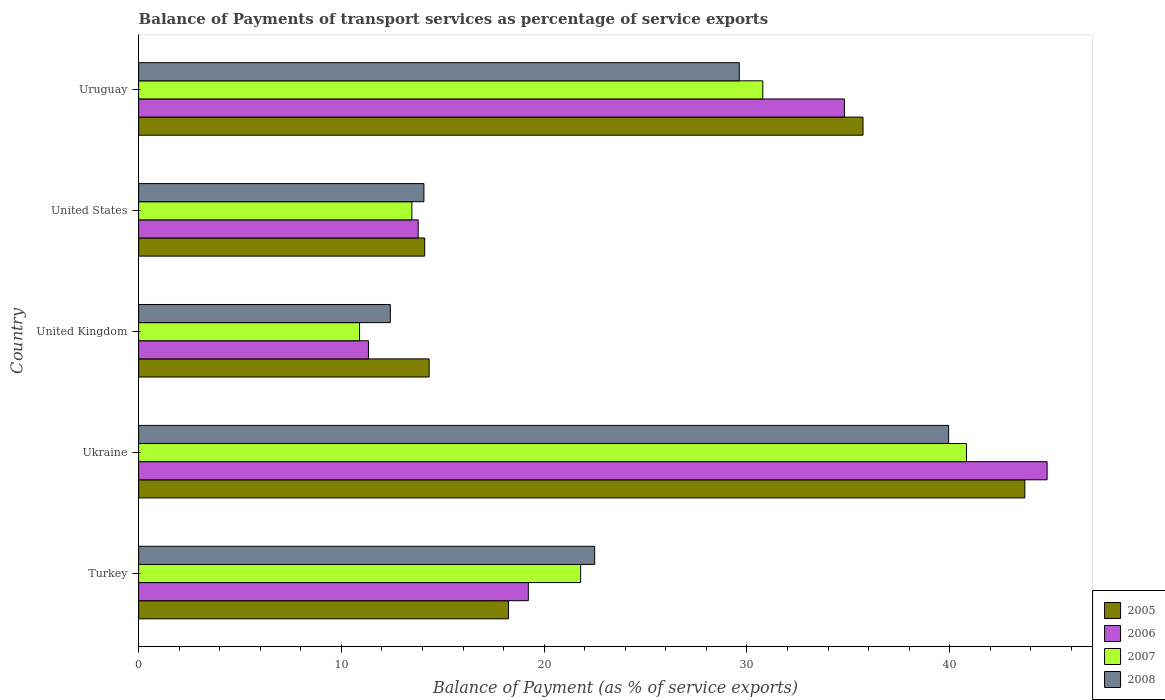How many different coloured bars are there?
Ensure brevity in your answer.  4. Are the number of bars on each tick of the Y-axis equal?
Provide a succinct answer. Yes. How many bars are there on the 1st tick from the top?
Give a very brief answer. 4. What is the label of the 1st group of bars from the top?
Give a very brief answer. Uruguay. What is the balance of payments of transport services in 2007 in United States?
Your answer should be very brief. 13.48. Across all countries, what is the maximum balance of payments of transport services in 2006?
Give a very brief answer. 44.81. Across all countries, what is the minimum balance of payments of transport services in 2006?
Keep it short and to the point. 11.33. In which country was the balance of payments of transport services in 2005 maximum?
Your answer should be compact. Ukraine. In which country was the balance of payments of transport services in 2008 minimum?
Offer a very short reply. United Kingdom. What is the total balance of payments of transport services in 2007 in the graph?
Give a very brief answer. 117.79. What is the difference between the balance of payments of transport services in 2008 in Ukraine and that in United States?
Provide a short and direct response. 25.88. What is the difference between the balance of payments of transport services in 2006 in United States and the balance of payments of transport services in 2008 in United Kingdom?
Your answer should be very brief. 1.37. What is the average balance of payments of transport services in 2006 per country?
Ensure brevity in your answer.  24.79. What is the difference between the balance of payments of transport services in 2005 and balance of payments of transport services in 2006 in United States?
Ensure brevity in your answer.  0.32. What is the ratio of the balance of payments of transport services in 2006 in Ukraine to that in United States?
Give a very brief answer. 3.25. What is the difference between the highest and the second highest balance of payments of transport services in 2007?
Offer a very short reply. 10.05. What is the difference between the highest and the lowest balance of payments of transport services in 2007?
Provide a succinct answer. 29.93. In how many countries, is the balance of payments of transport services in 2007 greater than the average balance of payments of transport services in 2007 taken over all countries?
Offer a very short reply. 2. Is it the case that in every country, the sum of the balance of payments of transport services in 2007 and balance of payments of transport services in 2006 is greater than the sum of balance of payments of transport services in 2005 and balance of payments of transport services in 2008?
Provide a succinct answer. No. What does the 4th bar from the bottom in Ukraine represents?
Ensure brevity in your answer.  2008. Is it the case that in every country, the sum of the balance of payments of transport services in 2008 and balance of payments of transport services in 2005 is greater than the balance of payments of transport services in 2007?
Your response must be concise. Yes. Are all the bars in the graph horizontal?
Provide a short and direct response. Yes. How many countries are there in the graph?
Ensure brevity in your answer.  5. What is the difference between two consecutive major ticks on the X-axis?
Your answer should be compact. 10. Does the graph contain grids?
Give a very brief answer. No. How are the legend labels stacked?
Offer a very short reply. Vertical. What is the title of the graph?
Provide a succinct answer. Balance of Payments of transport services as percentage of service exports. What is the label or title of the X-axis?
Offer a terse response. Balance of Payment (as % of service exports). What is the label or title of the Y-axis?
Your response must be concise. Country. What is the Balance of Payment (as % of service exports) in 2005 in Turkey?
Make the answer very short. 18.24. What is the Balance of Payment (as % of service exports) of 2006 in Turkey?
Provide a succinct answer. 19.22. What is the Balance of Payment (as % of service exports) of 2007 in Turkey?
Offer a terse response. 21.8. What is the Balance of Payment (as % of service exports) of 2008 in Turkey?
Make the answer very short. 22.49. What is the Balance of Payment (as % of service exports) of 2005 in Ukraine?
Provide a succinct answer. 43.71. What is the Balance of Payment (as % of service exports) of 2006 in Ukraine?
Make the answer very short. 44.81. What is the Balance of Payment (as % of service exports) in 2007 in Ukraine?
Ensure brevity in your answer.  40.83. What is the Balance of Payment (as % of service exports) in 2008 in Ukraine?
Keep it short and to the point. 39.95. What is the Balance of Payment (as % of service exports) of 2005 in United Kingdom?
Offer a terse response. 14.33. What is the Balance of Payment (as % of service exports) in 2006 in United Kingdom?
Provide a short and direct response. 11.33. What is the Balance of Payment (as % of service exports) in 2007 in United Kingdom?
Provide a short and direct response. 10.9. What is the Balance of Payment (as % of service exports) in 2008 in United Kingdom?
Your response must be concise. 12.41. What is the Balance of Payment (as % of service exports) in 2005 in United States?
Keep it short and to the point. 14.11. What is the Balance of Payment (as % of service exports) of 2006 in United States?
Keep it short and to the point. 13.79. What is the Balance of Payment (as % of service exports) of 2007 in United States?
Provide a short and direct response. 13.48. What is the Balance of Payment (as % of service exports) of 2008 in United States?
Ensure brevity in your answer.  14.07. What is the Balance of Payment (as % of service exports) in 2005 in Uruguay?
Your answer should be very brief. 35.73. What is the Balance of Payment (as % of service exports) of 2006 in Uruguay?
Make the answer very short. 34.81. What is the Balance of Payment (as % of service exports) of 2007 in Uruguay?
Provide a succinct answer. 30.78. What is the Balance of Payment (as % of service exports) of 2008 in Uruguay?
Offer a terse response. 29.62. Across all countries, what is the maximum Balance of Payment (as % of service exports) of 2005?
Give a very brief answer. 43.71. Across all countries, what is the maximum Balance of Payment (as % of service exports) in 2006?
Offer a terse response. 44.81. Across all countries, what is the maximum Balance of Payment (as % of service exports) in 2007?
Provide a succinct answer. 40.83. Across all countries, what is the maximum Balance of Payment (as % of service exports) of 2008?
Make the answer very short. 39.95. Across all countries, what is the minimum Balance of Payment (as % of service exports) in 2005?
Provide a short and direct response. 14.11. Across all countries, what is the minimum Balance of Payment (as % of service exports) in 2006?
Provide a short and direct response. 11.33. Across all countries, what is the minimum Balance of Payment (as % of service exports) in 2007?
Give a very brief answer. 10.9. Across all countries, what is the minimum Balance of Payment (as % of service exports) in 2008?
Provide a succinct answer. 12.41. What is the total Balance of Payment (as % of service exports) in 2005 in the graph?
Keep it short and to the point. 126.12. What is the total Balance of Payment (as % of service exports) of 2006 in the graph?
Offer a very short reply. 123.96. What is the total Balance of Payment (as % of service exports) of 2007 in the graph?
Provide a succinct answer. 117.79. What is the total Balance of Payment (as % of service exports) in 2008 in the graph?
Your answer should be compact. 118.55. What is the difference between the Balance of Payment (as % of service exports) in 2005 in Turkey and that in Ukraine?
Make the answer very short. -25.46. What is the difference between the Balance of Payment (as % of service exports) of 2006 in Turkey and that in Ukraine?
Give a very brief answer. -25.59. What is the difference between the Balance of Payment (as % of service exports) of 2007 in Turkey and that in Ukraine?
Keep it short and to the point. -19.03. What is the difference between the Balance of Payment (as % of service exports) of 2008 in Turkey and that in Ukraine?
Make the answer very short. -17.46. What is the difference between the Balance of Payment (as % of service exports) of 2005 in Turkey and that in United Kingdom?
Keep it short and to the point. 3.92. What is the difference between the Balance of Payment (as % of service exports) of 2006 in Turkey and that in United Kingdom?
Your answer should be compact. 7.89. What is the difference between the Balance of Payment (as % of service exports) of 2007 in Turkey and that in United Kingdom?
Your answer should be compact. 10.9. What is the difference between the Balance of Payment (as % of service exports) of 2008 in Turkey and that in United Kingdom?
Offer a very short reply. 10.08. What is the difference between the Balance of Payment (as % of service exports) of 2005 in Turkey and that in United States?
Make the answer very short. 4.14. What is the difference between the Balance of Payment (as % of service exports) of 2006 in Turkey and that in United States?
Your response must be concise. 5.43. What is the difference between the Balance of Payment (as % of service exports) in 2007 in Turkey and that in United States?
Give a very brief answer. 8.32. What is the difference between the Balance of Payment (as % of service exports) in 2008 in Turkey and that in United States?
Your answer should be compact. 8.42. What is the difference between the Balance of Payment (as % of service exports) in 2005 in Turkey and that in Uruguay?
Your response must be concise. -17.48. What is the difference between the Balance of Payment (as % of service exports) in 2006 in Turkey and that in Uruguay?
Your answer should be compact. -15.59. What is the difference between the Balance of Payment (as % of service exports) in 2007 in Turkey and that in Uruguay?
Your response must be concise. -8.98. What is the difference between the Balance of Payment (as % of service exports) of 2008 in Turkey and that in Uruguay?
Keep it short and to the point. -7.13. What is the difference between the Balance of Payment (as % of service exports) of 2005 in Ukraine and that in United Kingdom?
Keep it short and to the point. 29.38. What is the difference between the Balance of Payment (as % of service exports) of 2006 in Ukraine and that in United Kingdom?
Offer a terse response. 33.47. What is the difference between the Balance of Payment (as % of service exports) in 2007 in Ukraine and that in United Kingdom?
Provide a succinct answer. 29.93. What is the difference between the Balance of Payment (as % of service exports) of 2008 in Ukraine and that in United Kingdom?
Keep it short and to the point. 27.54. What is the difference between the Balance of Payment (as % of service exports) in 2005 in Ukraine and that in United States?
Your answer should be very brief. 29.6. What is the difference between the Balance of Payment (as % of service exports) in 2006 in Ukraine and that in United States?
Provide a short and direct response. 31.02. What is the difference between the Balance of Payment (as % of service exports) of 2007 in Ukraine and that in United States?
Your answer should be very brief. 27.35. What is the difference between the Balance of Payment (as % of service exports) in 2008 in Ukraine and that in United States?
Provide a short and direct response. 25.88. What is the difference between the Balance of Payment (as % of service exports) of 2005 in Ukraine and that in Uruguay?
Offer a terse response. 7.98. What is the difference between the Balance of Payment (as % of service exports) of 2006 in Ukraine and that in Uruguay?
Your answer should be compact. 10. What is the difference between the Balance of Payment (as % of service exports) in 2007 in Ukraine and that in Uruguay?
Offer a terse response. 10.05. What is the difference between the Balance of Payment (as % of service exports) of 2008 in Ukraine and that in Uruguay?
Offer a terse response. 10.32. What is the difference between the Balance of Payment (as % of service exports) of 2005 in United Kingdom and that in United States?
Your response must be concise. 0.22. What is the difference between the Balance of Payment (as % of service exports) in 2006 in United Kingdom and that in United States?
Offer a terse response. -2.45. What is the difference between the Balance of Payment (as % of service exports) in 2007 in United Kingdom and that in United States?
Provide a succinct answer. -2.58. What is the difference between the Balance of Payment (as % of service exports) in 2008 in United Kingdom and that in United States?
Your answer should be very brief. -1.66. What is the difference between the Balance of Payment (as % of service exports) in 2005 in United Kingdom and that in Uruguay?
Offer a very short reply. -21.4. What is the difference between the Balance of Payment (as % of service exports) of 2006 in United Kingdom and that in Uruguay?
Offer a terse response. -23.47. What is the difference between the Balance of Payment (as % of service exports) in 2007 in United Kingdom and that in Uruguay?
Your answer should be very brief. -19.89. What is the difference between the Balance of Payment (as % of service exports) of 2008 in United Kingdom and that in Uruguay?
Make the answer very short. -17.21. What is the difference between the Balance of Payment (as % of service exports) in 2005 in United States and that in Uruguay?
Ensure brevity in your answer.  -21.62. What is the difference between the Balance of Payment (as % of service exports) in 2006 in United States and that in Uruguay?
Offer a terse response. -21.02. What is the difference between the Balance of Payment (as % of service exports) in 2007 in United States and that in Uruguay?
Offer a terse response. -17.31. What is the difference between the Balance of Payment (as % of service exports) of 2008 in United States and that in Uruguay?
Your answer should be compact. -15.55. What is the difference between the Balance of Payment (as % of service exports) in 2005 in Turkey and the Balance of Payment (as % of service exports) in 2006 in Ukraine?
Your answer should be very brief. -26.56. What is the difference between the Balance of Payment (as % of service exports) of 2005 in Turkey and the Balance of Payment (as % of service exports) of 2007 in Ukraine?
Ensure brevity in your answer.  -22.58. What is the difference between the Balance of Payment (as % of service exports) in 2005 in Turkey and the Balance of Payment (as % of service exports) in 2008 in Ukraine?
Ensure brevity in your answer.  -21.7. What is the difference between the Balance of Payment (as % of service exports) of 2006 in Turkey and the Balance of Payment (as % of service exports) of 2007 in Ukraine?
Give a very brief answer. -21.61. What is the difference between the Balance of Payment (as % of service exports) of 2006 in Turkey and the Balance of Payment (as % of service exports) of 2008 in Ukraine?
Provide a short and direct response. -20.73. What is the difference between the Balance of Payment (as % of service exports) in 2007 in Turkey and the Balance of Payment (as % of service exports) in 2008 in Ukraine?
Your response must be concise. -18.15. What is the difference between the Balance of Payment (as % of service exports) in 2005 in Turkey and the Balance of Payment (as % of service exports) in 2006 in United Kingdom?
Make the answer very short. 6.91. What is the difference between the Balance of Payment (as % of service exports) of 2005 in Turkey and the Balance of Payment (as % of service exports) of 2007 in United Kingdom?
Your answer should be compact. 7.35. What is the difference between the Balance of Payment (as % of service exports) of 2005 in Turkey and the Balance of Payment (as % of service exports) of 2008 in United Kingdom?
Offer a terse response. 5.83. What is the difference between the Balance of Payment (as % of service exports) of 2006 in Turkey and the Balance of Payment (as % of service exports) of 2007 in United Kingdom?
Your answer should be very brief. 8.32. What is the difference between the Balance of Payment (as % of service exports) in 2006 in Turkey and the Balance of Payment (as % of service exports) in 2008 in United Kingdom?
Offer a terse response. 6.81. What is the difference between the Balance of Payment (as % of service exports) of 2007 in Turkey and the Balance of Payment (as % of service exports) of 2008 in United Kingdom?
Give a very brief answer. 9.39. What is the difference between the Balance of Payment (as % of service exports) of 2005 in Turkey and the Balance of Payment (as % of service exports) of 2006 in United States?
Offer a very short reply. 4.46. What is the difference between the Balance of Payment (as % of service exports) in 2005 in Turkey and the Balance of Payment (as % of service exports) in 2007 in United States?
Your response must be concise. 4.77. What is the difference between the Balance of Payment (as % of service exports) in 2005 in Turkey and the Balance of Payment (as % of service exports) in 2008 in United States?
Your answer should be compact. 4.17. What is the difference between the Balance of Payment (as % of service exports) in 2006 in Turkey and the Balance of Payment (as % of service exports) in 2007 in United States?
Ensure brevity in your answer.  5.74. What is the difference between the Balance of Payment (as % of service exports) of 2006 in Turkey and the Balance of Payment (as % of service exports) of 2008 in United States?
Your answer should be compact. 5.15. What is the difference between the Balance of Payment (as % of service exports) in 2007 in Turkey and the Balance of Payment (as % of service exports) in 2008 in United States?
Provide a short and direct response. 7.73. What is the difference between the Balance of Payment (as % of service exports) of 2005 in Turkey and the Balance of Payment (as % of service exports) of 2006 in Uruguay?
Your answer should be compact. -16.56. What is the difference between the Balance of Payment (as % of service exports) of 2005 in Turkey and the Balance of Payment (as % of service exports) of 2007 in Uruguay?
Provide a succinct answer. -12.54. What is the difference between the Balance of Payment (as % of service exports) of 2005 in Turkey and the Balance of Payment (as % of service exports) of 2008 in Uruguay?
Your response must be concise. -11.38. What is the difference between the Balance of Payment (as % of service exports) in 2006 in Turkey and the Balance of Payment (as % of service exports) in 2007 in Uruguay?
Provide a succinct answer. -11.56. What is the difference between the Balance of Payment (as % of service exports) of 2006 in Turkey and the Balance of Payment (as % of service exports) of 2008 in Uruguay?
Make the answer very short. -10.4. What is the difference between the Balance of Payment (as % of service exports) in 2007 in Turkey and the Balance of Payment (as % of service exports) in 2008 in Uruguay?
Your answer should be very brief. -7.82. What is the difference between the Balance of Payment (as % of service exports) of 2005 in Ukraine and the Balance of Payment (as % of service exports) of 2006 in United Kingdom?
Keep it short and to the point. 32.37. What is the difference between the Balance of Payment (as % of service exports) in 2005 in Ukraine and the Balance of Payment (as % of service exports) in 2007 in United Kingdom?
Provide a succinct answer. 32.81. What is the difference between the Balance of Payment (as % of service exports) of 2005 in Ukraine and the Balance of Payment (as % of service exports) of 2008 in United Kingdom?
Make the answer very short. 31.29. What is the difference between the Balance of Payment (as % of service exports) in 2006 in Ukraine and the Balance of Payment (as % of service exports) in 2007 in United Kingdom?
Provide a short and direct response. 33.91. What is the difference between the Balance of Payment (as % of service exports) of 2006 in Ukraine and the Balance of Payment (as % of service exports) of 2008 in United Kingdom?
Ensure brevity in your answer.  32.39. What is the difference between the Balance of Payment (as % of service exports) in 2007 in Ukraine and the Balance of Payment (as % of service exports) in 2008 in United Kingdom?
Provide a succinct answer. 28.41. What is the difference between the Balance of Payment (as % of service exports) of 2005 in Ukraine and the Balance of Payment (as % of service exports) of 2006 in United States?
Provide a short and direct response. 29.92. What is the difference between the Balance of Payment (as % of service exports) of 2005 in Ukraine and the Balance of Payment (as % of service exports) of 2007 in United States?
Make the answer very short. 30.23. What is the difference between the Balance of Payment (as % of service exports) of 2005 in Ukraine and the Balance of Payment (as % of service exports) of 2008 in United States?
Offer a terse response. 29.64. What is the difference between the Balance of Payment (as % of service exports) in 2006 in Ukraine and the Balance of Payment (as % of service exports) in 2007 in United States?
Keep it short and to the point. 31.33. What is the difference between the Balance of Payment (as % of service exports) of 2006 in Ukraine and the Balance of Payment (as % of service exports) of 2008 in United States?
Offer a very short reply. 30.74. What is the difference between the Balance of Payment (as % of service exports) of 2007 in Ukraine and the Balance of Payment (as % of service exports) of 2008 in United States?
Ensure brevity in your answer.  26.76. What is the difference between the Balance of Payment (as % of service exports) of 2005 in Ukraine and the Balance of Payment (as % of service exports) of 2006 in Uruguay?
Provide a short and direct response. 8.9. What is the difference between the Balance of Payment (as % of service exports) in 2005 in Ukraine and the Balance of Payment (as % of service exports) in 2007 in Uruguay?
Ensure brevity in your answer.  12.93. What is the difference between the Balance of Payment (as % of service exports) in 2005 in Ukraine and the Balance of Payment (as % of service exports) in 2008 in Uruguay?
Your answer should be very brief. 14.08. What is the difference between the Balance of Payment (as % of service exports) in 2006 in Ukraine and the Balance of Payment (as % of service exports) in 2007 in Uruguay?
Provide a succinct answer. 14.02. What is the difference between the Balance of Payment (as % of service exports) of 2006 in Ukraine and the Balance of Payment (as % of service exports) of 2008 in Uruguay?
Provide a short and direct response. 15.18. What is the difference between the Balance of Payment (as % of service exports) in 2007 in Ukraine and the Balance of Payment (as % of service exports) in 2008 in Uruguay?
Offer a very short reply. 11.21. What is the difference between the Balance of Payment (as % of service exports) of 2005 in United Kingdom and the Balance of Payment (as % of service exports) of 2006 in United States?
Provide a succinct answer. 0.54. What is the difference between the Balance of Payment (as % of service exports) in 2005 in United Kingdom and the Balance of Payment (as % of service exports) in 2007 in United States?
Offer a terse response. 0.85. What is the difference between the Balance of Payment (as % of service exports) in 2005 in United Kingdom and the Balance of Payment (as % of service exports) in 2008 in United States?
Provide a short and direct response. 0.26. What is the difference between the Balance of Payment (as % of service exports) in 2006 in United Kingdom and the Balance of Payment (as % of service exports) in 2007 in United States?
Give a very brief answer. -2.14. What is the difference between the Balance of Payment (as % of service exports) in 2006 in United Kingdom and the Balance of Payment (as % of service exports) in 2008 in United States?
Provide a short and direct response. -2.74. What is the difference between the Balance of Payment (as % of service exports) in 2007 in United Kingdom and the Balance of Payment (as % of service exports) in 2008 in United States?
Provide a short and direct response. -3.17. What is the difference between the Balance of Payment (as % of service exports) in 2005 in United Kingdom and the Balance of Payment (as % of service exports) in 2006 in Uruguay?
Provide a short and direct response. -20.48. What is the difference between the Balance of Payment (as % of service exports) in 2005 in United Kingdom and the Balance of Payment (as % of service exports) in 2007 in Uruguay?
Make the answer very short. -16.45. What is the difference between the Balance of Payment (as % of service exports) of 2005 in United Kingdom and the Balance of Payment (as % of service exports) of 2008 in Uruguay?
Offer a very short reply. -15.3. What is the difference between the Balance of Payment (as % of service exports) in 2006 in United Kingdom and the Balance of Payment (as % of service exports) in 2007 in Uruguay?
Make the answer very short. -19.45. What is the difference between the Balance of Payment (as % of service exports) in 2006 in United Kingdom and the Balance of Payment (as % of service exports) in 2008 in Uruguay?
Offer a terse response. -18.29. What is the difference between the Balance of Payment (as % of service exports) of 2007 in United Kingdom and the Balance of Payment (as % of service exports) of 2008 in Uruguay?
Give a very brief answer. -18.73. What is the difference between the Balance of Payment (as % of service exports) in 2005 in United States and the Balance of Payment (as % of service exports) in 2006 in Uruguay?
Provide a short and direct response. -20.7. What is the difference between the Balance of Payment (as % of service exports) in 2005 in United States and the Balance of Payment (as % of service exports) in 2007 in Uruguay?
Your response must be concise. -16.68. What is the difference between the Balance of Payment (as % of service exports) in 2005 in United States and the Balance of Payment (as % of service exports) in 2008 in Uruguay?
Give a very brief answer. -15.52. What is the difference between the Balance of Payment (as % of service exports) of 2006 in United States and the Balance of Payment (as % of service exports) of 2007 in Uruguay?
Your answer should be very brief. -16.99. What is the difference between the Balance of Payment (as % of service exports) of 2006 in United States and the Balance of Payment (as % of service exports) of 2008 in Uruguay?
Your answer should be compact. -15.84. What is the difference between the Balance of Payment (as % of service exports) of 2007 in United States and the Balance of Payment (as % of service exports) of 2008 in Uruguay?
Provide a short and direct response. -16.15. What is the average Balance of Payment (as % of service exports) of 2005 per country?
Make the answer very short. 25.22. What is the average Balance of Payment (as % of service exports) in 2006 per country?
Offer a very short reply. 24.79. What is the average Balance of Payment (as % of service exports) in 2007 per country?
Make the answer very short. 23.56. What is the average Balance of Payment (as % of service exports) in 2008 per country?
Give a very brief answer. 23.71. What is the difference between the Balance of Payment (as % of service exports) in 2005 and Balance of Payment (as % of service exports) in 2006 in Turkey?
Ensure brevity in your answer.  -0.98. What is the difference between the Balance of Payment (as % of service exports) in 2005 and Balance of Payment (as % of service exports) in 2007 in Turkey?
Offer a terse response. -3.56. What is the difference between the Balance of Payment (as % of service exports) of 2005 and Balance of Payment (as % of service exports) of 2008 in Turkey?
Keep it short and to the point. -4.25. What is the difference between the Balance of Payment (as % of service exports) of 2006 and Balance of Payment (as % of service exports) of 2007 in Turkey?
Keep it short and to the point. -2.58. What is the difference between the Balance of Payment (as % of service exports) in 2006 and Balance of Payment (as % of service exports) in 2008 in Turkey?
Give a very brief answer. -3.27. What is the difference between the Balance of Payment (as % of service exports) of 2007 and Balance of Payment (as % of service exports) of 2008 in Turkey?
Keep it short and to the point. -0.69. What is the difference between the Balance of Payment (as % of service exports) in 2005 and Balance of Payment (as % of service exports) in 2006 in Ukraine?
Make the answer very short. -1.1. What is the difference between the Balance of Payment (as % of service exports) of 2005 and Balance of Payment (as % of service exports) of 2007 in Ukraine?
Your answer should be very brief. 2.88. What is the difference between the Balance of Payment (as % of service exports) in 2005 and Balance of Payment (as % of service exports) in 2008 in Ukraine?
Your answer should be compact. 3.76. What is the difference between the Balance of Payment (as % of service exports) of 2006 and Balance of Payment (as % of service exports) of 2007 in Ukraine?
Offer a terse response. 3.98. What is the difference between the Balance of Payment (as % of service exports) of 2006 and Balance of Payment (as % of service exports) of 2008 in Ukraine?
Your response must be concise. 4.86. What is the difference between the Balance of Payment (as % of service exports) of 2007 and Balance of Payment (as % of service exports) of 2008 in Ukraine?
Offer a very short reply. 0.88. What is the difference between the Balance of Payment (as % of service exports) in 2005 and Balance of Payment (as % of service exports) in 2006 in United Kingdom?
Offer a terse response. 2.99. What is the difference between the Balance of Payment (as % of service exports) of 2005 and Balance of Payment (as % of service exports) of 2007 in United Kingdom?
Make the answer very short. 3.43. What is the difference between the Balance of Payment (as % of service exports) of 2005 and Balance of Payment (as % of service exports) of 2008 in United Kingdom?
Provide a succinct answer. 1.91. What is the difference between the Balance of Payment (as % of service exports) in 2006 and Balance of Payment (as % of service exports) in 2007 in United Kingdom?
Offer a terse response. 0.44. What is the difference between the Balance of Payment (as % of service exports) in 2006 and Balance of Payment (as % of service exports) in 2008 in United Kingdom?
Keep it short and to the point. -1.08. What is the difference between the Balance of Payment (as % of service exports) in 2007 and Balance of Payment (as % of service exports) in 2008 in United Kingdom?
Provide a short and direct response. -1.52. What is the difference between the Balance of Payment (as % of service exports) of 2005 and Balance of Payment (as % of service exports) of 2006 in United States?
Ensure brevity in your answer.  0.32. What is the difference between the Balance of Payment (as % of service exports) of 2005 and Balance of Payment (as % of service exports) of 2007 in United States?
Your answer should be compact. 0.63. What is the difference between the Balance of Payment (as % of service exports) in 2005 and Balance of Payment (as % of service exports) in 2008 in United States?
Your answer should be very brief. 0.04. What is the difference between the Balance of Payment (as % of service exports) in 2006 and Balance of Payment (as % of service exports) in 2007 in United States?
Offer a terse response. 0.31. What is the difference between the Balance of Payment (as % of service exports) in 2006 and Balance of Payment (as % of service exports) in 2008 in United States?
Offer a terse response. -0.28. What is the difference between the Balance of Payment (as % of service exports) of 2007 and Balance of Payment (as % of service exports) of 2008 in United States?
Your answer should be compact. -0.59. What is the difference between the Balance of Payment (as % of service exports) in 2005 and Balance of Payment (as % of service exports) in 2006 in Uruguay?
Make the answer very short. 0.92. What is the difference between the Balance of Payment (as % of service exports) in 2005 and Balance of Payment (as % of service exports) in 2007 in Uruguay?
Provide a short and direct response. 4.94. What is the difference between the Balance of Payment (as % of service exports) of 2005 and Balance of Payment (as % of service exports) of 2008 in Uruguay?
Your answer should be compact. 6.1. What is the difference between the Balance of Payment (as % of service exports) of 2006 and Balance of Payment (as % of service exports) of 2007 in Uruguay?
Ensure brevity in your answer.  4.03. What is the difference between the Balance of Payment (as % of service exports) of 2006 and Balance of Payment (as % of service exports) of 2008 in Uruguay?
Provide a succinct answer. 5.18. What is the difference between the Balance of Payment (as % of service exports) in 2007 and Balance of Payment (as % of service exports) in 2008 in Uruguay?
Offer a terse response. 1.16. What is the ratio of the Balance of Payment (as % of service exports) of 2005 in Turkey to that in Ukraine?
Provide a succinct answer. 0.42. What is the ratio of the Balance of Payment (as % of service exports) in 2006 in Turkey to that in Ukraine?
Keep it short and to the point. 0.43. What is the ratio of the Balance of Payment (as % of service exports) in 2007 in Turkey to that in Ukraine?
Keep it short and to the point. 0.53. What is the ratio of the Balance of Payment (as % of service exports) of 2008 in Turkey to that in Ukraine?
Provide a short and direct response. 0.56. What is the ratio of the Balance of Payment (as % of service exports) of 2005 in Turkey to that in United Kingdom?
Offer a terse response. 1.27. What is the ratio of the Balance of Payment (as % of service exports) in 2006 in Turkey to that in United Kingdom?
Keep it short and to the point. 1.7. What is the ratio of the Balance of Payment (as % of service exports) of 2007 in Turkey to that in United Kingdom?
Offer a very short reply. 2. What is the ratio of the Balance of Payment (as % of service exports) in 2008 in Turkey to that in United Kingdom?
Provide a short and direct response. 1.81. What is the ratio of the Balance of Payment (as % of service exports) of 2005 in Turkey to that in United States?
Make the answer very short. 1.29. What is the ratio of the Balance of Payment (as % of service exports) of 2006 in Turkey to that in United States?
Give a very brief answer. 1.39. What is the ratio of the Balance of Payment (as % of service exports) in 2007 in Turkey to that in United States?
Provide a short and direct response. 1.62. What is the ratio of the Balance of Payment (as % of service exports) of 2008 in Turkey to that in United States?
Your response must be concise. 1.6. What is the ratio of the Balance of Payment (as % of service exports) of 2005 in Turkey to that in Uruguay?
Make the answer very short. 0.51. What is the ratio of the Balance of Payment (as % of service exports) of 2006 in Turkey to that in Uruguay?
Provide a succinct answer. 0.55. What is the ratio of the Balance of Payment (as % of service exports) in 2007 in Turkey to that in Uruguay?
Your answer should be compact. 0.71. What is the ratio of the Balance of Payment (as % of service exports) of 2008 in Turkey to that in Uruguay?
Provide a succinct answer. 0.76. What is the ratio of the Balance of Payment (as % of service exports) in 2005 in Ukraine to that in United Kingdom?
Your answer should be compact. 3.05. What is the ratio of the Balance of Payment (as % of service exports) of 2006 in Ukraine to that in United Kingdom?
Provide a short and direct response. 3.95. What is the ratio of the Balance of Payment (as % of service exports) in 2007 in Ukraine to that in United Kingdom?
Ensure brevity in your answer.  3.75. What is the ratio of the Balance of Payment (as % of service exports) in 2008 in Ukraine to that in United Kingdom?
Provide a short and direct response. 3.22. What is the ratio of the Balance of Payment (as % of service exports) in 2005 in Ukraine to that in United States?
Your response must be concise. 3.1. What is the ratio of the Balance of Payment (as % of service exports) of 2006 in Ukraine to that in United States?
Ensure brevity in your answer.  3.25. What is the ratio of the Balance of Payment (as % of service exports) of 2007 in Ukraine to that in United States?
Your answer should be compact. 3.03. What is the ratio of the Balance of Payment (as % of service exports) of 2008 in Ukraine to that in United States?
Provide a short and direct response. 2.84. What is the ratio of the Balance of Payment (as % of service exports) of 2005 in Ukraine to that in Uruguay?
Ensure brevity in your answer.  1.22. What is the ratio of the Balance of Payment (as % of service exports) of 2006 in Ukraine to that in Uruguay?
Offer a terse response. 1.29. What is the ratio of the Balance of Payment (as % of service exports) in 2007 in Ukraine to that in Uruguay?
Offer a terse response. 1.33. What is the ratio of the Balance of Payment (as % of service exports) in 2008 in Ukraine to that in Uruguay?
Provide a succinct answer. 1.35. What is the ratio of the Balance of Payment (as % of service exports) in 2005 in United Kingdom to that in United States?
Offer a terse response. 1.02. What is the ratio of the Balance of Payment (as % of service exports) of 2006 in United Kingdom to that in United States?
Your answer should be very brief. 0.82. What is the ratio of the Balance of Payment (as % of service exports) of 2007 in United Kingdom to that in United States?
Give a very brief answer. 0.81. What is the ratio of the Balance of Payment (as % of service exports) of 2008 in United Kingdom to that in United States?
Offer a terse response. 0.88. What is the ratio of the Balance of Payment (as % of service exports) in 2005 in United Kingdom to that in Uruguay?
Offer a very short reply. 0.4. What is the ratio of the Balance of Payment (as % of service exports) of 2006 in United Kingdom to that in Uruguay?
Provide a short and direct response. 0.33. What is the ratio of the Balance of Payment (as % of service exports) in 2007 in United Kingdom to that in Uruguay?
Make the answer very short. 0.35. What is the ratio of the Balance of Payment (as % of service exports) in 2008 in United Kingdom to that in Uruguay?
Give a very brief answer. 0.42. What is the ratio of the Balance of Payment (as % of service exports) in 2005 in United States to that in Uruguay?
Ensure brevity in your answer.  0.39. What is the ratio of the Balance of Payment (as % of service exports) of 2006 in United States to that in Uruguay?
Provide a succinct answer. 0.4. What is the ratio of the Balance of Payment (as % of service exports) of 2007 in United States to that in Uruguay?
Offer a terse response. 0.44. What is the ratio of the Balance of Payment (as % of service exports) of 2008 in United States to that in Uruguay?
Give a very brief answer. 0.47. What is the difference between the highest and the second highest Balance of Payment (as % of service exports) of 2005?
Provide a succinct answer. 7.98. What is the difference between the highest and the second highest Balance of Payment (as % of service exports) of 2006?
Offer a terse response. 10. What is the difference between the highest and the second highest Balance of Payment (as % of service exports) of 2007?
Ensure brevity in your answer.  10.05. What is the difference between the highest and the second highest Balance of Payment (as % of service exports) in 2008?
Provide a short and direct response. 10.32. What is the difference between the highest and the lowest Balance of Payment (as % of service exports) in 2005?
Your answer should be compact. 29.6. What is the difference between the highest and the lowest Balance of Payment (as % of service exports) of 2006?
Provide a succinct answer. 33.47. What is the difference between the highest and the lowest Balance of Payment (as % of service exports) in 2007?
Your response must be concise. 29.93. What is the difference between the highest and the lowest Balance of Payment (as % of service exports) of 2008?
Offer a terse response. 27.54. 